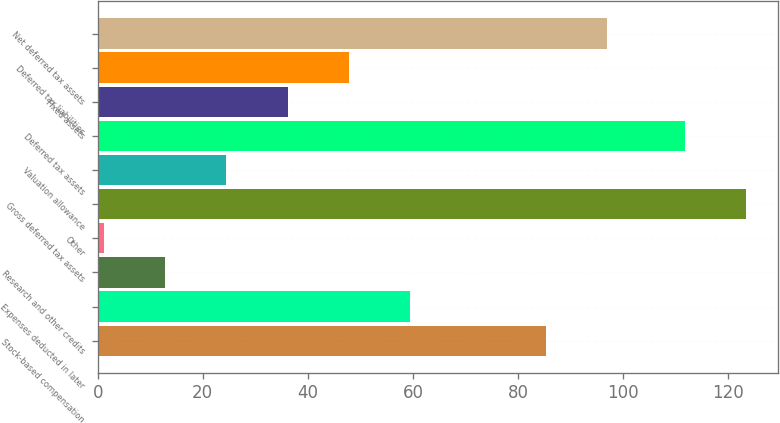<chart> <loc_0><loc_0><loc_500><loc_500><bar_chart><fcel>Stock-based compensation<fcel>Expenses deducted in later<fcel>Research and other credits<fcel>Other<fcel>Gross deferred tax assets<fcel>Valuation allowance<fcel>Deferred tax assets<fcel>Fixed assets<fcel>Deferred tax liabilities<fcel>Net deferred tax assets<nl><fcel>85.3<fcel>59.45<fcel>12.85<fcel>1.2<fcel>123.35<fcel>24.5<fcel>111.7<fcel>36.15<fcel>47.8<fcel>96.95<nl></chart> 